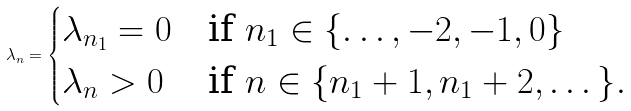Convert formula to latex. <formula><loc_0><loc_0><loc_500><loc_500>\lambda _ { n } = \begin{cases} \lambda _ { n _ { 1 } } = 0 & \text {if $n_{1}\in \{\dots, -2, -1, 0 \}$} \\ \lambda _ { n } > 0 & \text {if $n \in \{n_{1}+1, n_{1}+2, \dots\}$} . \\ \end{cases}</formula> 